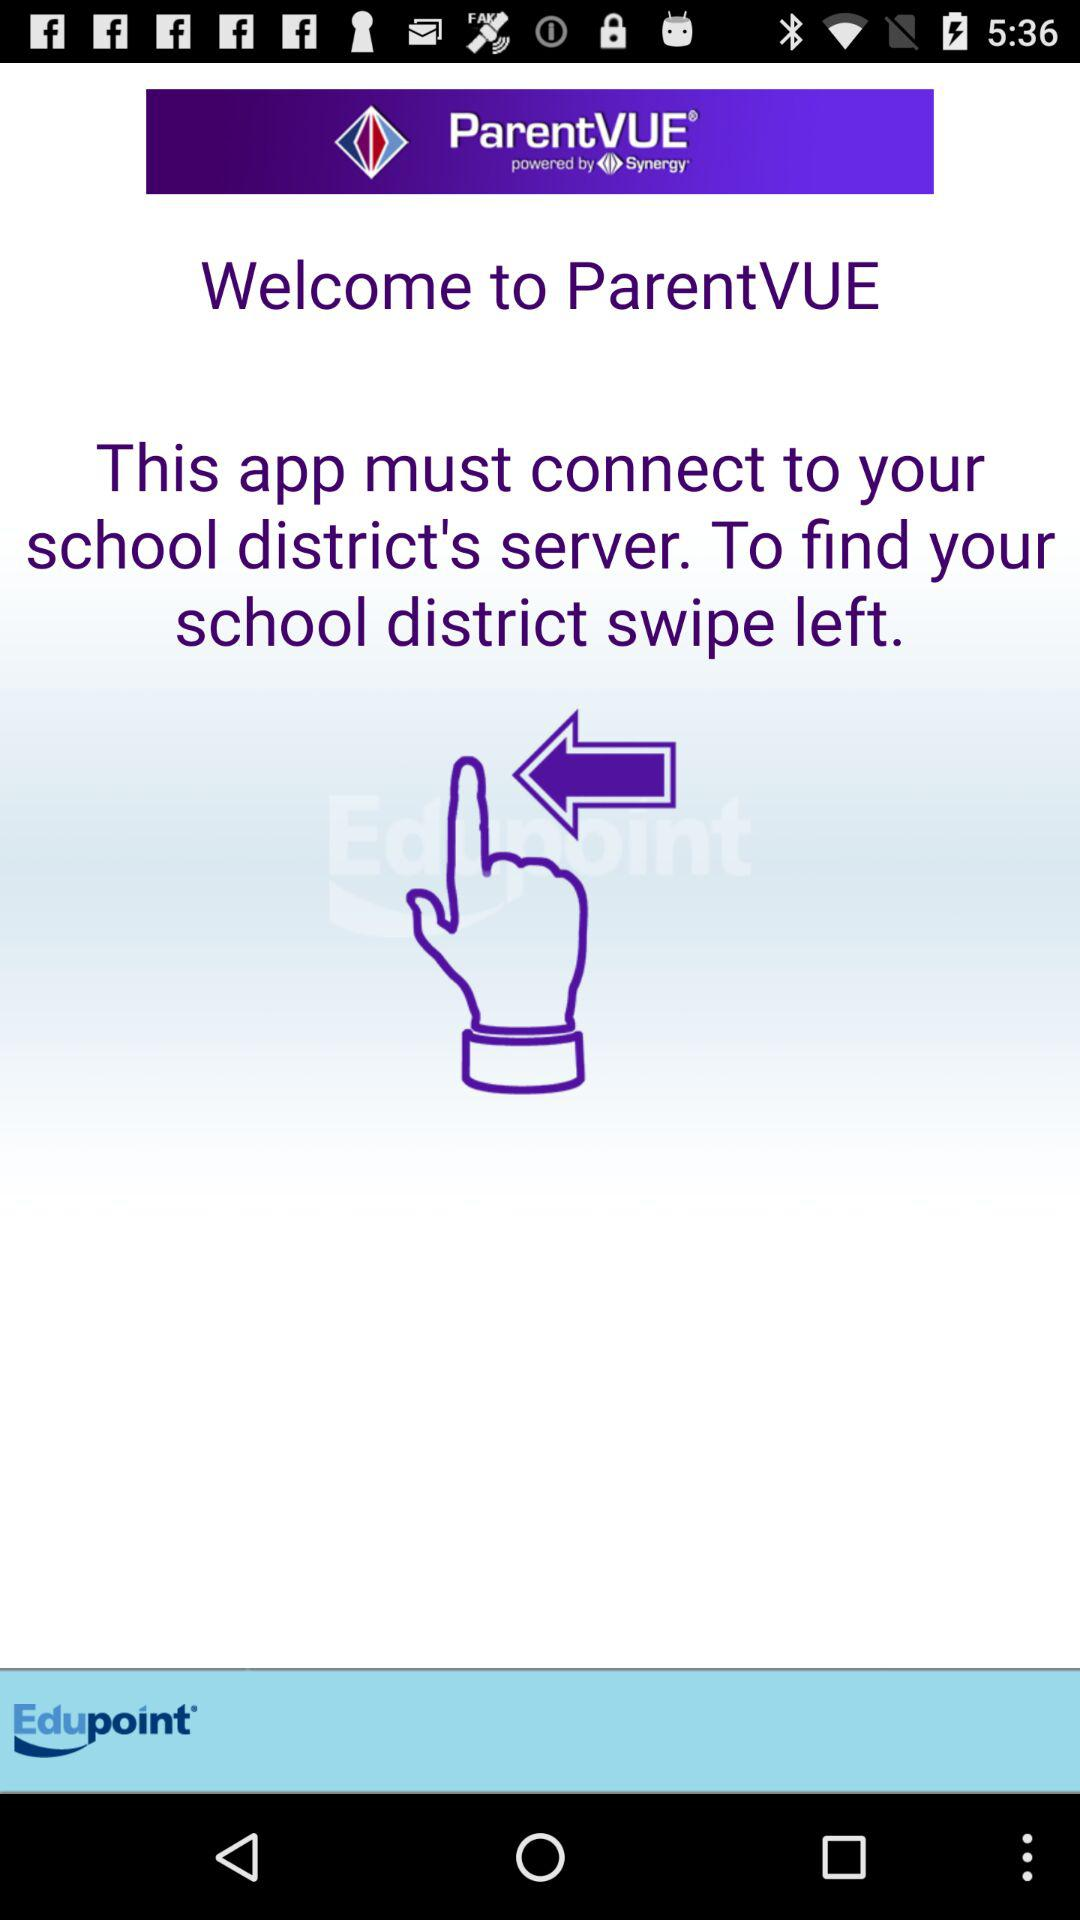What do we need to do to find our school district? To find your school district, swipe left. 